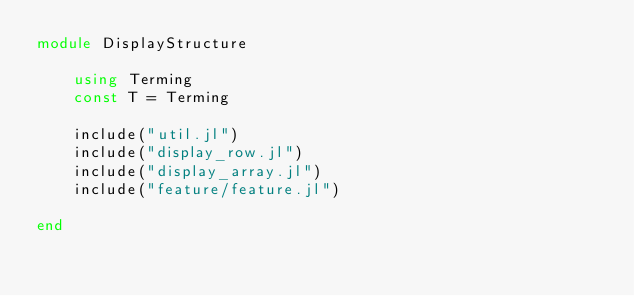<code> <loc_0><loc_0><loc_500><loc_500><_Julia_>module DisplayStructure

    using Terming
    const T = Terming

    include("util.jl")
    include("display_row.jl")
    include("display_array.jl")
    include("feature/feature.jl")

end
</code> 